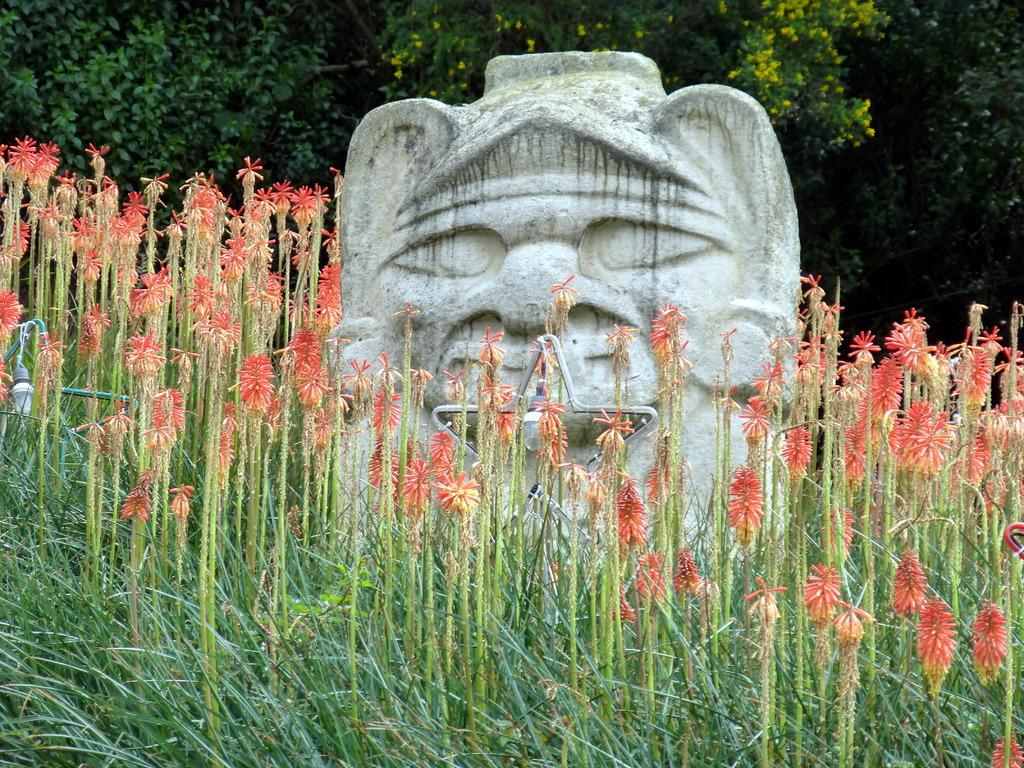What type of living organisms can be seen in the image? Plants can be seen in the image. What can be used to provide illumination in the image? There is a light in the image. What type of artwork is present in the image? There is a sculpture in the image. What type of vegetation with flowers can be seen in the background of the image? There are trees with flowers in the background of the image. Can you see any ice in the image? There is no ice present in the image. What type of tooth is visible in the image? There are no teeth present in the image. 